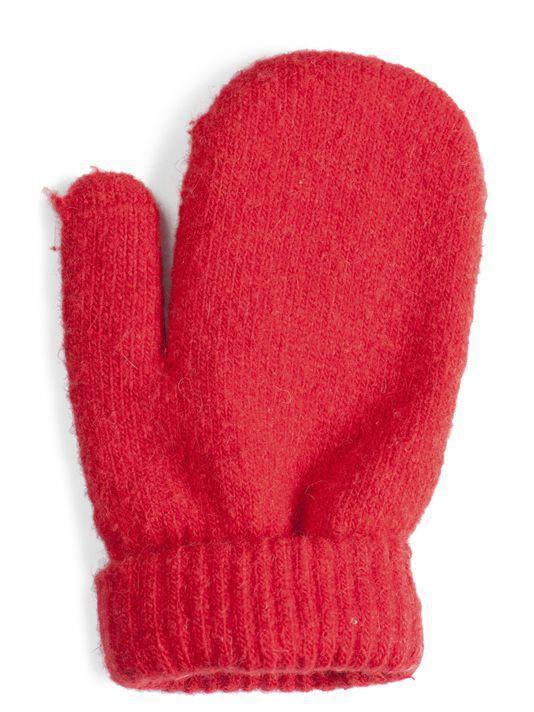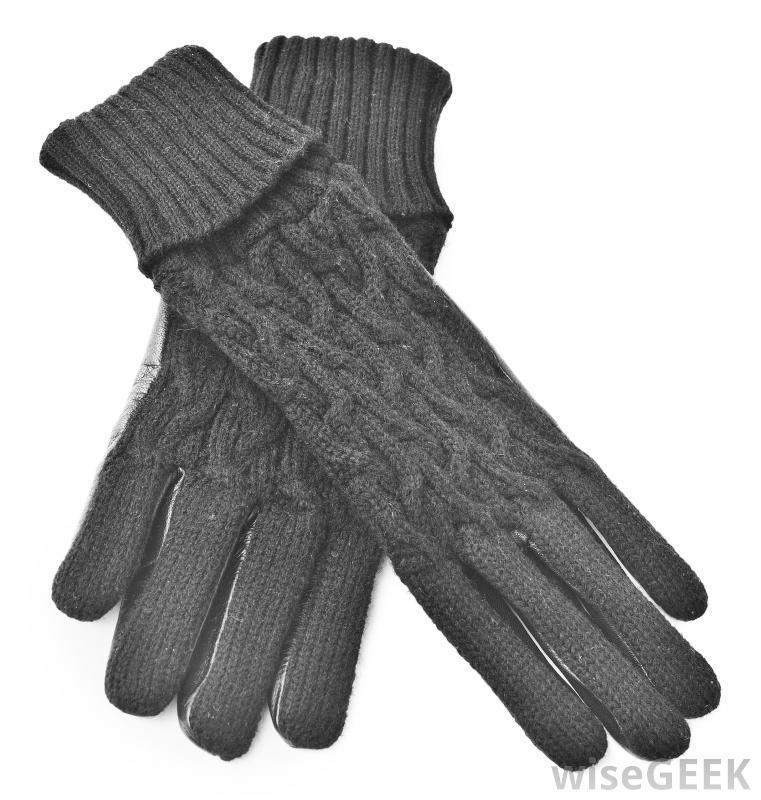The first image is the image on the left, the second image is the image on the right. Evaluate the accuracy of this statement regarding the images: "the gloves on the right don't have cut off fingers". Is it true? Answer yes or no. Yes. The first image is the image on the left, the second image is the image on the right. Given the left and right images, does the statement "Both gloves have detachable fingers" hold true? Answer yes or no. No. 